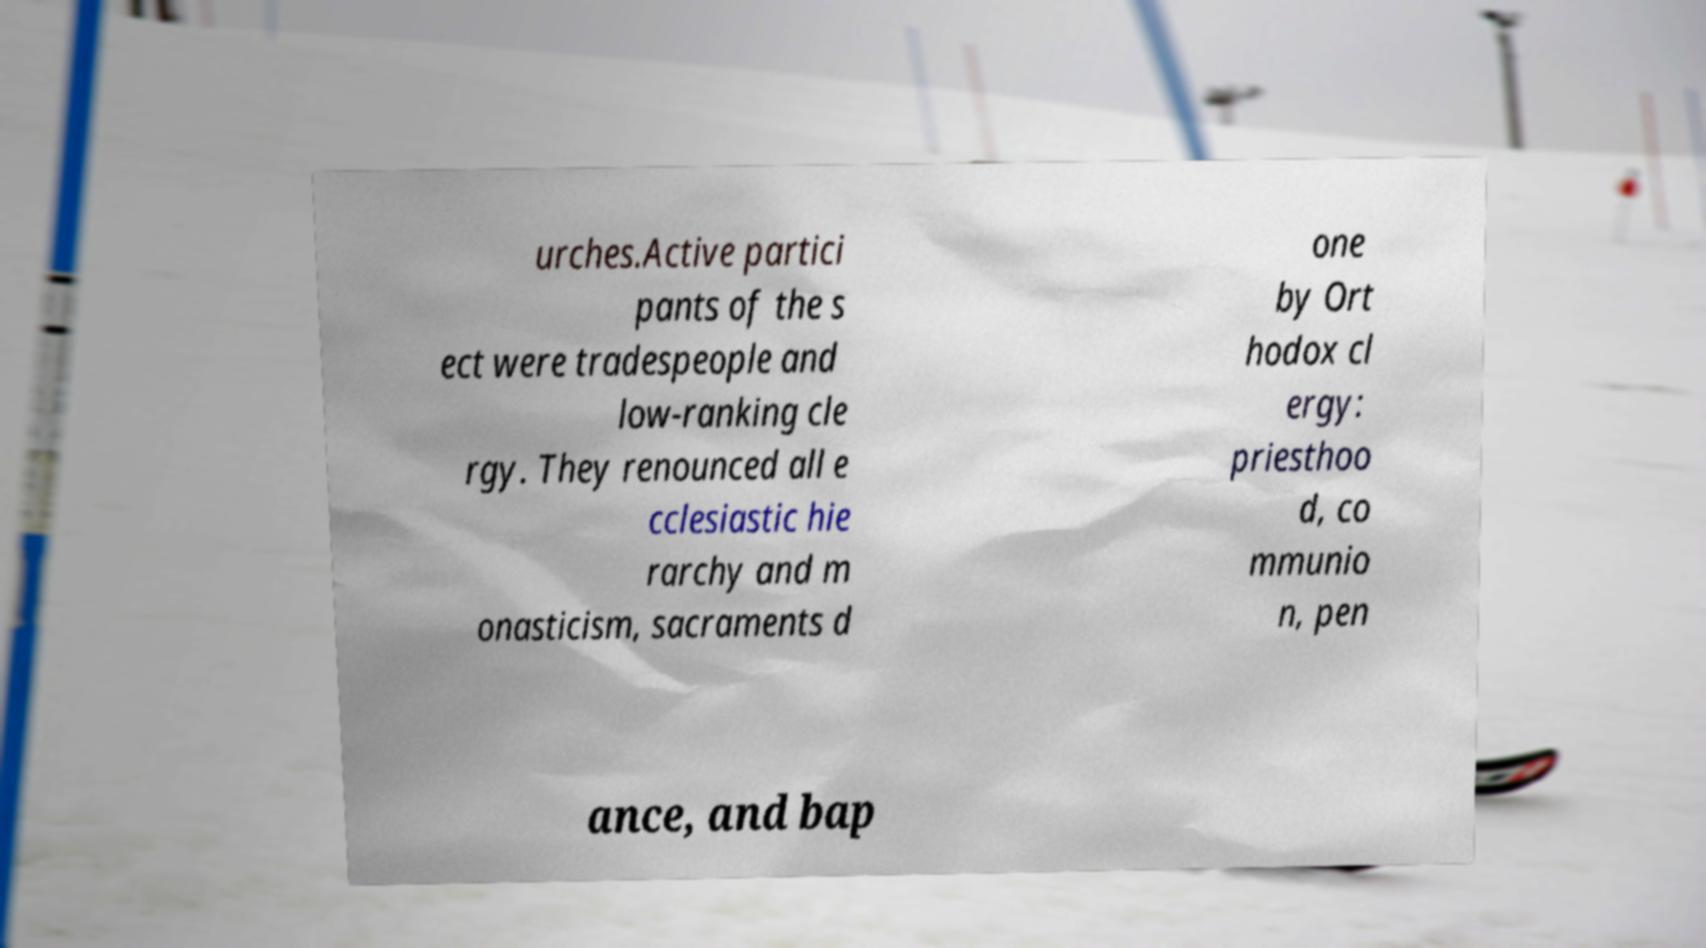There's text embedded in this image that I need extracted. Can you transcribe it verbatim? urches.Active partici pants of the s ect were tradespeople and low-ranking cle rgy. They renounced all e cclesiastic hie rarchy and m onasticism, sacraments d one by Ort hodox cl ergy: priesthoo d, co mmunio n, pen ance, and bap 